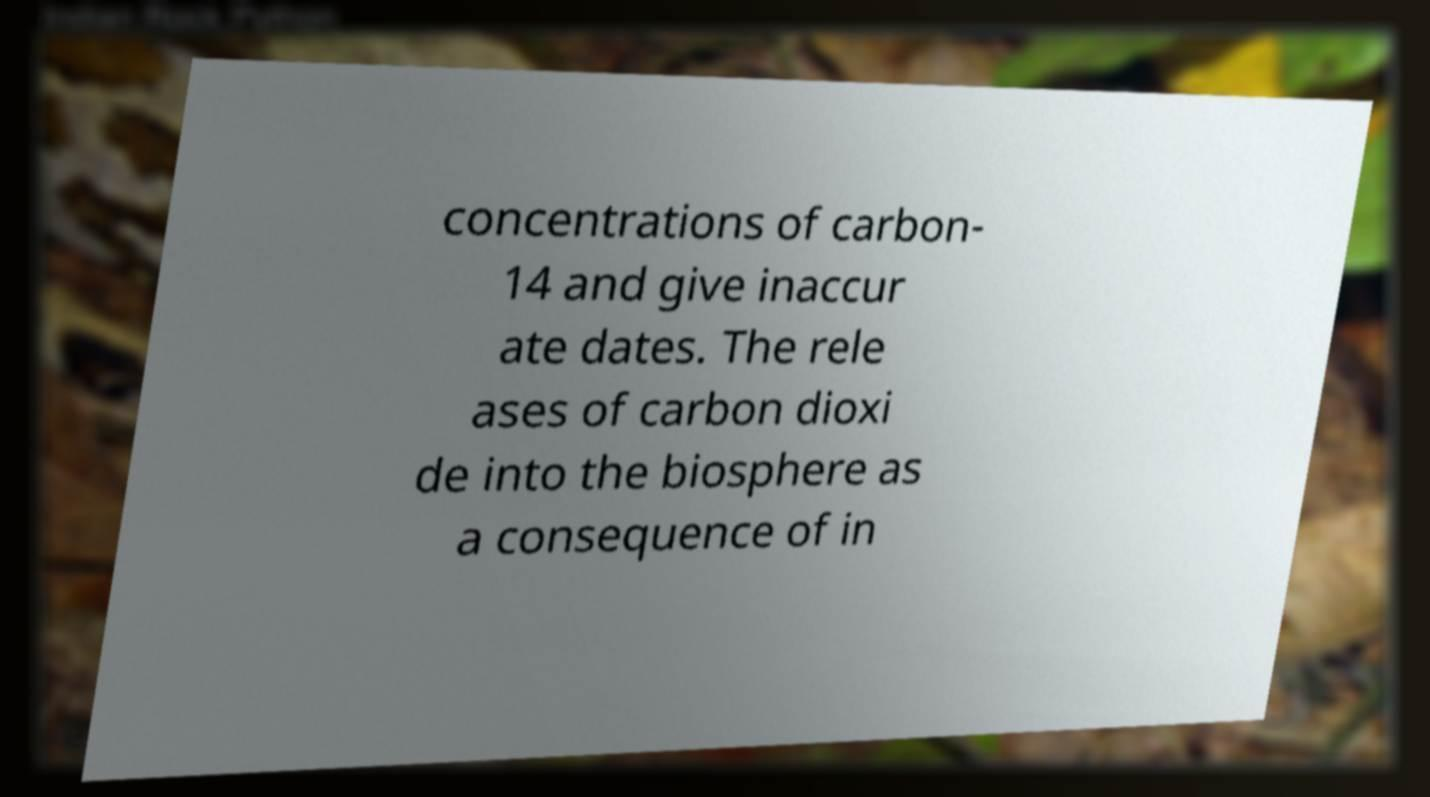Could you assist in decoding the text presented in this image and type it out clearly? concentrations of carbon- 14 and give inaccur ate dates. The rele ases of carbon dioxi de into the biosphere as a consequence of in 